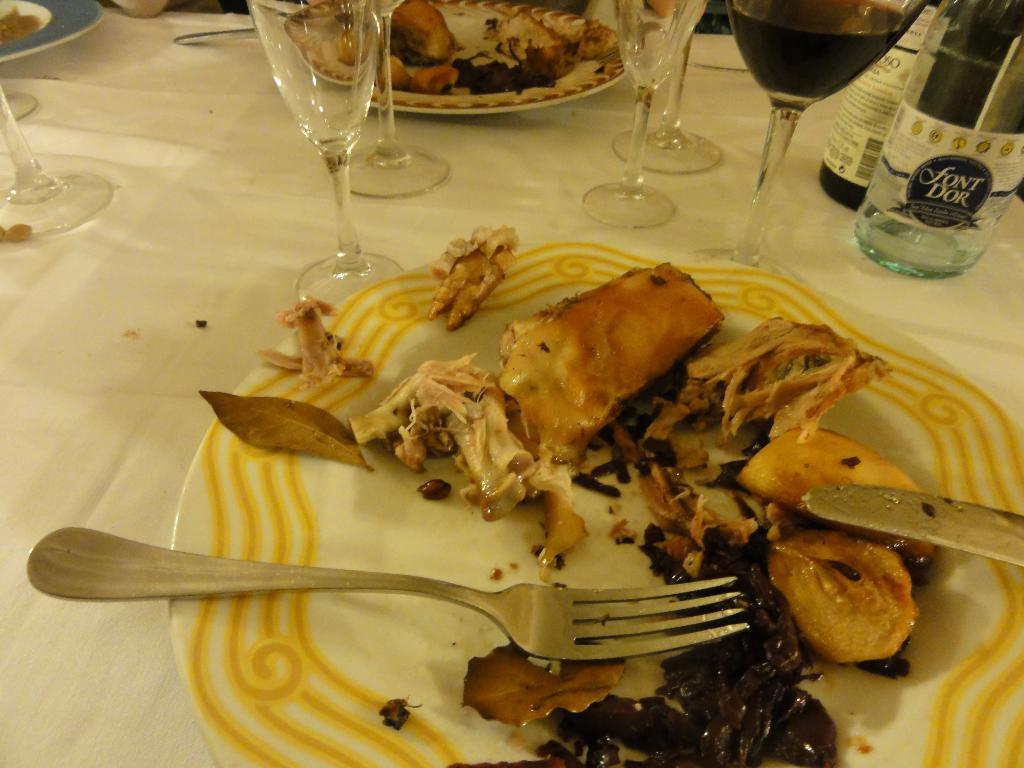What is present on the table in the image? There is a plate, glasses, a bottle, a fork, and a knife in the image. What can be found on the plate? There are eatables on the plate. What might be used to consume the eatables on the plate? The fork and knife in the image can be used to consume the eatables. What type of lock is visible on the plate in the image? There is no lock present on the plate or in the image. What time of day is it in the image, considering it might be lunchtime? The image does not provide any information about the time of day, so it cannot be determined if it might be lunchtime. 